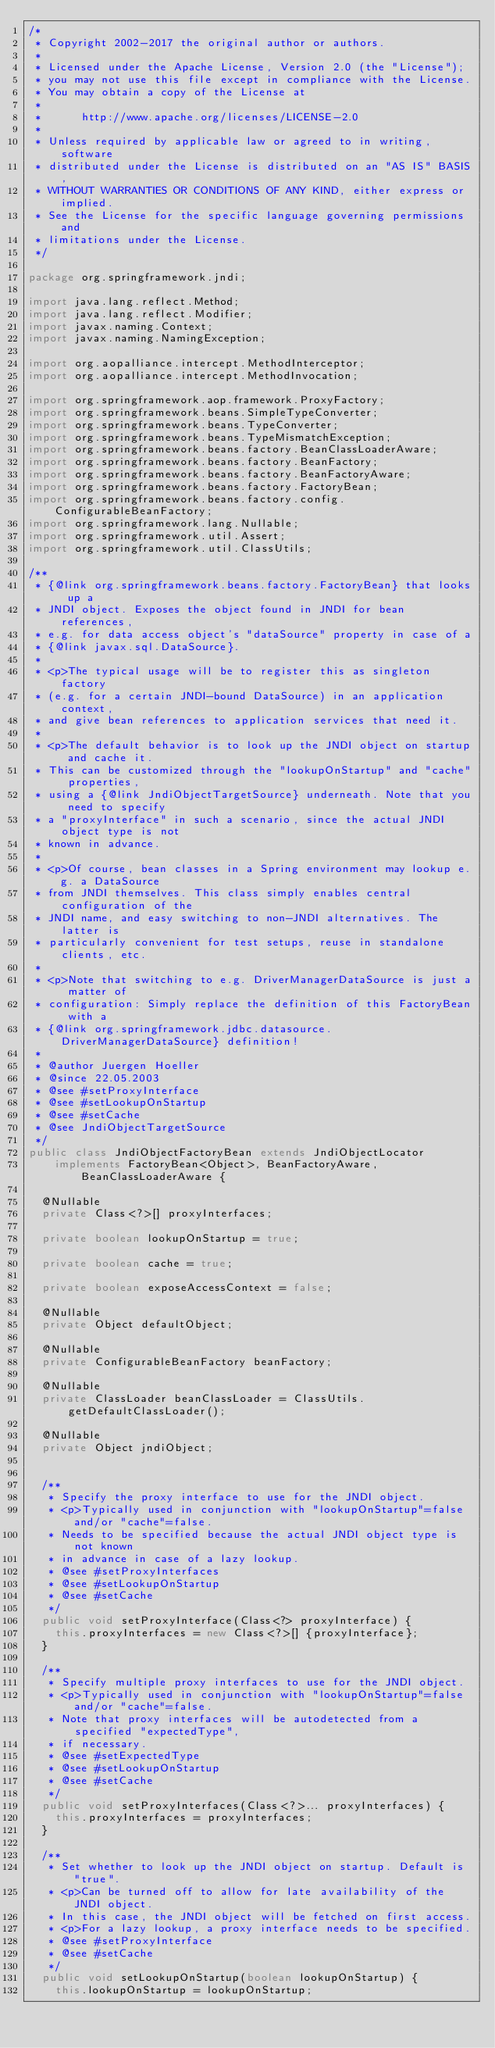Convert code to text. <code><loc_0><loc_0><loc_500><loc_500><_Java_>/*
 * Copyright 2002-2017 the original author or authors.
 *
 * Licensed under the Apache License, Version 2.0 (the "License");
 * you may not use this file except in compliance with the License.
 * You may obtain a copy of the License at
 *
 *      http://www.apache.org/licenses/LICENSE-2.0
 *
 * Unless required by applicable law or agreed to in writing, software
 * distributed under the License is distributed on an "AS IS" BASIS,
 * WITHOUT WARRANTIES OR CONDITIONS OF ANY KIND, either express or implied.
 * See the License for the specific language governing permissions and
 * limitations under the License.
 */

package org.springframework.jndi;

import java.lang.reflect.Method;
import java.lang.reflect.Modifier;
import javax.naming.Context;
import javax.naming.NamingException;

import org.aopalliance.intercept.MethodInterceptor;
import org.aopalliance.intercept.MethodInvocation;

import org.springframework.aop.framework.ProxyFactory;
import org.springframework.beans.SimpleTypeConverter;
import org.springframework.beans.TypeConverter;
import org.springframework.beans.TypeMismatchException;
import org.springframework.beans.factory.BeanClassLoaderAware;
import org.springframework.beans.factory.BeanFactory;
import org.springframework.beans.factory.BeanFactoryAware;
import org.springframework.beans.factory.FactoryBean;
import org.springframework.beans.factory.config.ConfigurableBeanFactory;
import org.springframework.lang.Nullable;
import org.springframework.util.Assert;
import org.springframework.util.ClassUtils;

/**
 * {@link org.springframework.beans.factory.FactoryBean} that looks up a
 * JNDI object. Exposes the object found in JNDI for bean references,
 * e.g. for data access object's "dataSource" property in case of a
 * {@link javax.sql.DataSource}.
 *
 * <p>The typical usage will be to register this as singleton factory
 * (e.g. for a certain JNDI-bound DataSource) in an application context,
 * and give bean references to application services that need it.
 *
 * <p>The default behavior is to look up the JNDI object on startup and cache it.
 * This can be customized through the "lookupOnStartup" and "cache" properties,
 * using a {@link JndiObjectTargetSource} underneath. Note that you need to specify
 * a "proxyInterface" in such a scenario, since the actual JNDI object type is not
 * known in advance.
 *
 * <p>Of course, bean classes in a Spring environment may lookup e.g. a DataSource
 * from JNDI themselves. This class simply enables central configuration of the
 * JNDI name, and easy switching to non-JNDI alternatives. The latter is
 * particularly convenient for test setups, reuse in standalone clients, etc.
 *
 * <p>Note that switching to e.g. DriverManagerDataSource is just a matter of
 * configuration: Simply replace the definition of this FactoryBean with a
 * {@link org.springframework.jdbc.datasource.DriverManagerDataSource} definition!
 *
 * @author Juergen Hoeller
 * @since 22.05.2003
 * @see #setProxyInterface
 * @see #setLookupOnStartup
 * @see #setCache
 * @see JndiObjectTargetSource
 */
public class JndiObjectFactoryBean extends JndiObjectLocator
		implements FactoryBean<Object>, BeanFactoryAware, BeanClassLoaderAware {

	@Nullable
	private Class<?>[] proxyInterfaces;

	private boolean lookupOnStartup = true;

	private boolean cache = true;

	private boolean exposeAccessContext = false;

	@Nullable
	private Object defaultObject;

	@Nullable
	private ConfigurableBeanFactory beanFactory;

	@Nullable
	private ClassLoader beanClassLoader = ClassUtils.getDefaultClassLoader();

	@Nullable
	private Object jndiObject;


	/**
	 * Specify the proxy interface to use for the JNDI object.
	 * <p>Typically used in conjunction with "lookupOnStartup"=false and/or "cache"=false.
	 * Needs to be specified because the actual JNDI object type is not known
	 * in advance in case of a lazy lookup.
	 * @see #setProxyInterfaces
	 * @see #setLookupOnStartup
	 * @see #setCache
	 */
	public void setProxyInterface(Class<?> proxyInterface) {
		this.proxyInterfaces = new Class<?>[] {proxyInterface};
	}

	/**
	 * Specify multiple proxy interfaces to use for the JNDI object.
	 * <p>Typically used in conjunction with "lookupOnStartup"=false and/or "cache"=false.
	 * Note that proxy interfaces will be autodetected from a specified "expectedType",
	 * if necessary.
	 * @see #setExpectedType
	 * @see #setLookupOnStartup
	 * @see #setCache
	 */
	public void setProxyInterfaces(Class<?>... proxyInterfaces) {
		this.proxyInterfaces = proxyInterfaces;
	}

	/**
	 * Set whether to look up the JNDI object on startup. Default is "true".
	 * <p>Can be turned off to allow for late availability of the JNDI object.
	 * In this case, the JNDI object will be fetched on first access.
	 * <p>For a lazy lookup, a proxy interface needs to be specified.
	 * @see #setProxyInterface
	 * @see #setCache
	 */
	public void setLookupOnStartup(boolean lookupOnStartup) {
		this.lookupOnStartup = lookupOnStartup;</code> 